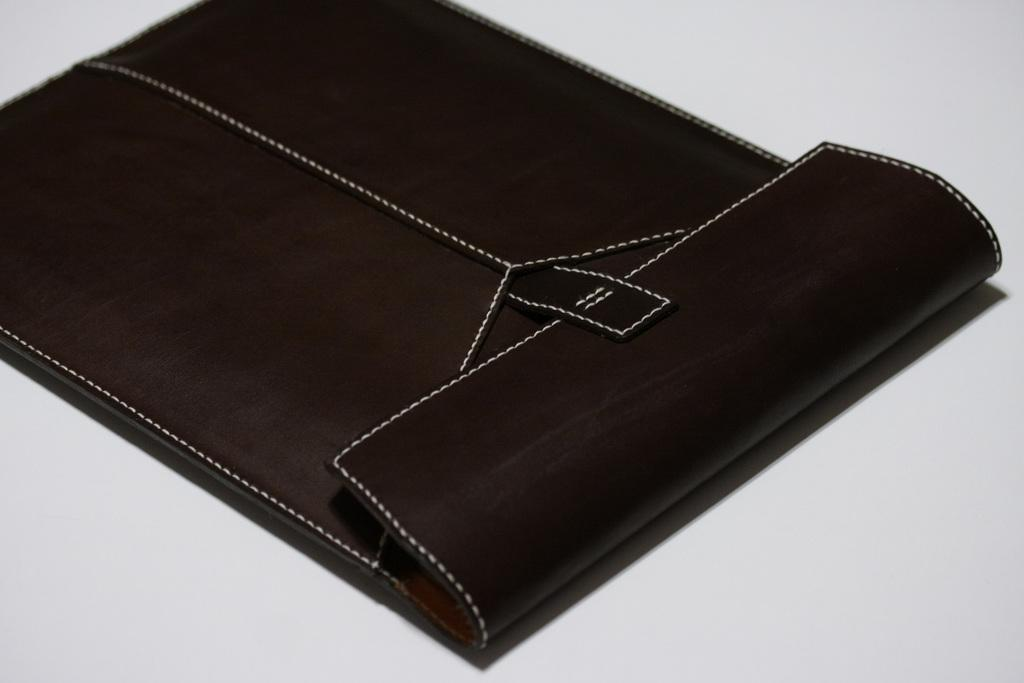What is the color of the object in the image? The object in the image is brown-colored. What is the color of the surface on which the object is placed? The surface is white. What is the temperature of the object in the image? The provided facts do not mention the temperature of the object, so it cannot be determined from the image. Can you tell me the angle at which the object is positioned on the white surface? The provided facts do not mention the angle of the object, so it cannot be determined from the image. Is there a squirrel visible in the image? There is no mention of a squirrel in the provided facts, so it cannot be determined from the image. 